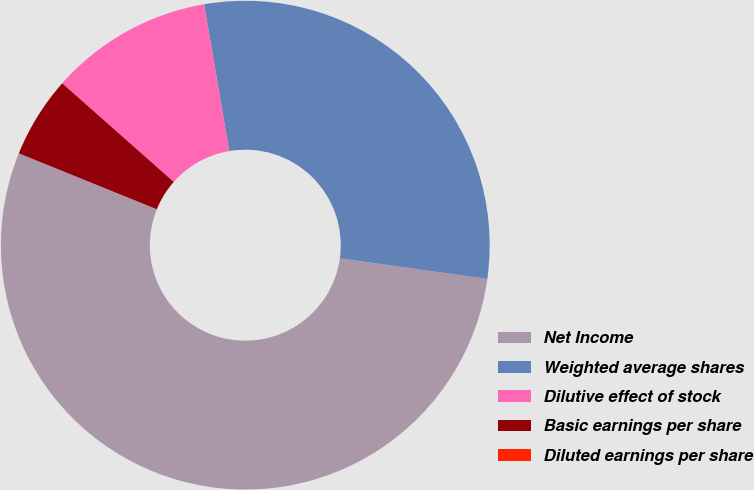<chart> <loc_0><loc_0><loc_500><loc_500><pie_chart><fcel>Net Income<fcel>Weighted average shares<fcel>Dilutive effect of stock<fcel>Basic earnings per share<fcel>Diluted earnings per share<nl><fcel>53.92%<fcel>29.9%<fcel>10.78%<fcel>5.39%<fcel>0.0%<nl></chart> 